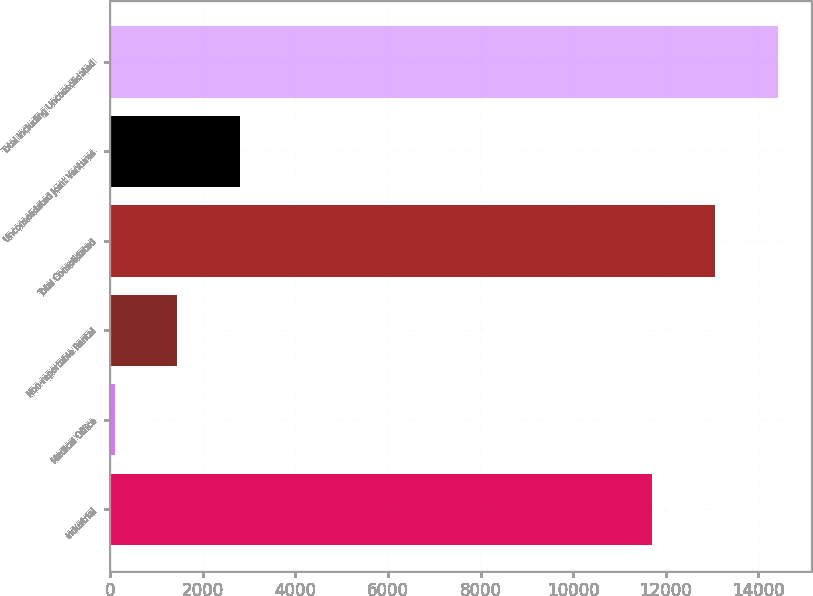Convert chart to OTSL. <chart><loc_0><loc_0><loc_500><loc_500><bar_chart><fcel>Industrial<fcel>Medical Office<fcel>Non-reportable Rental<fcel>Total Consolidated<fcel>Unconsolidated Joint Ventures<fcel>Total Including Unconsolidated<nl><fcel>11708<fcel>96<fcel>1453.4<fcel>13065.4<fcel>2810.8<fcel>14422.8<nl></chart> 